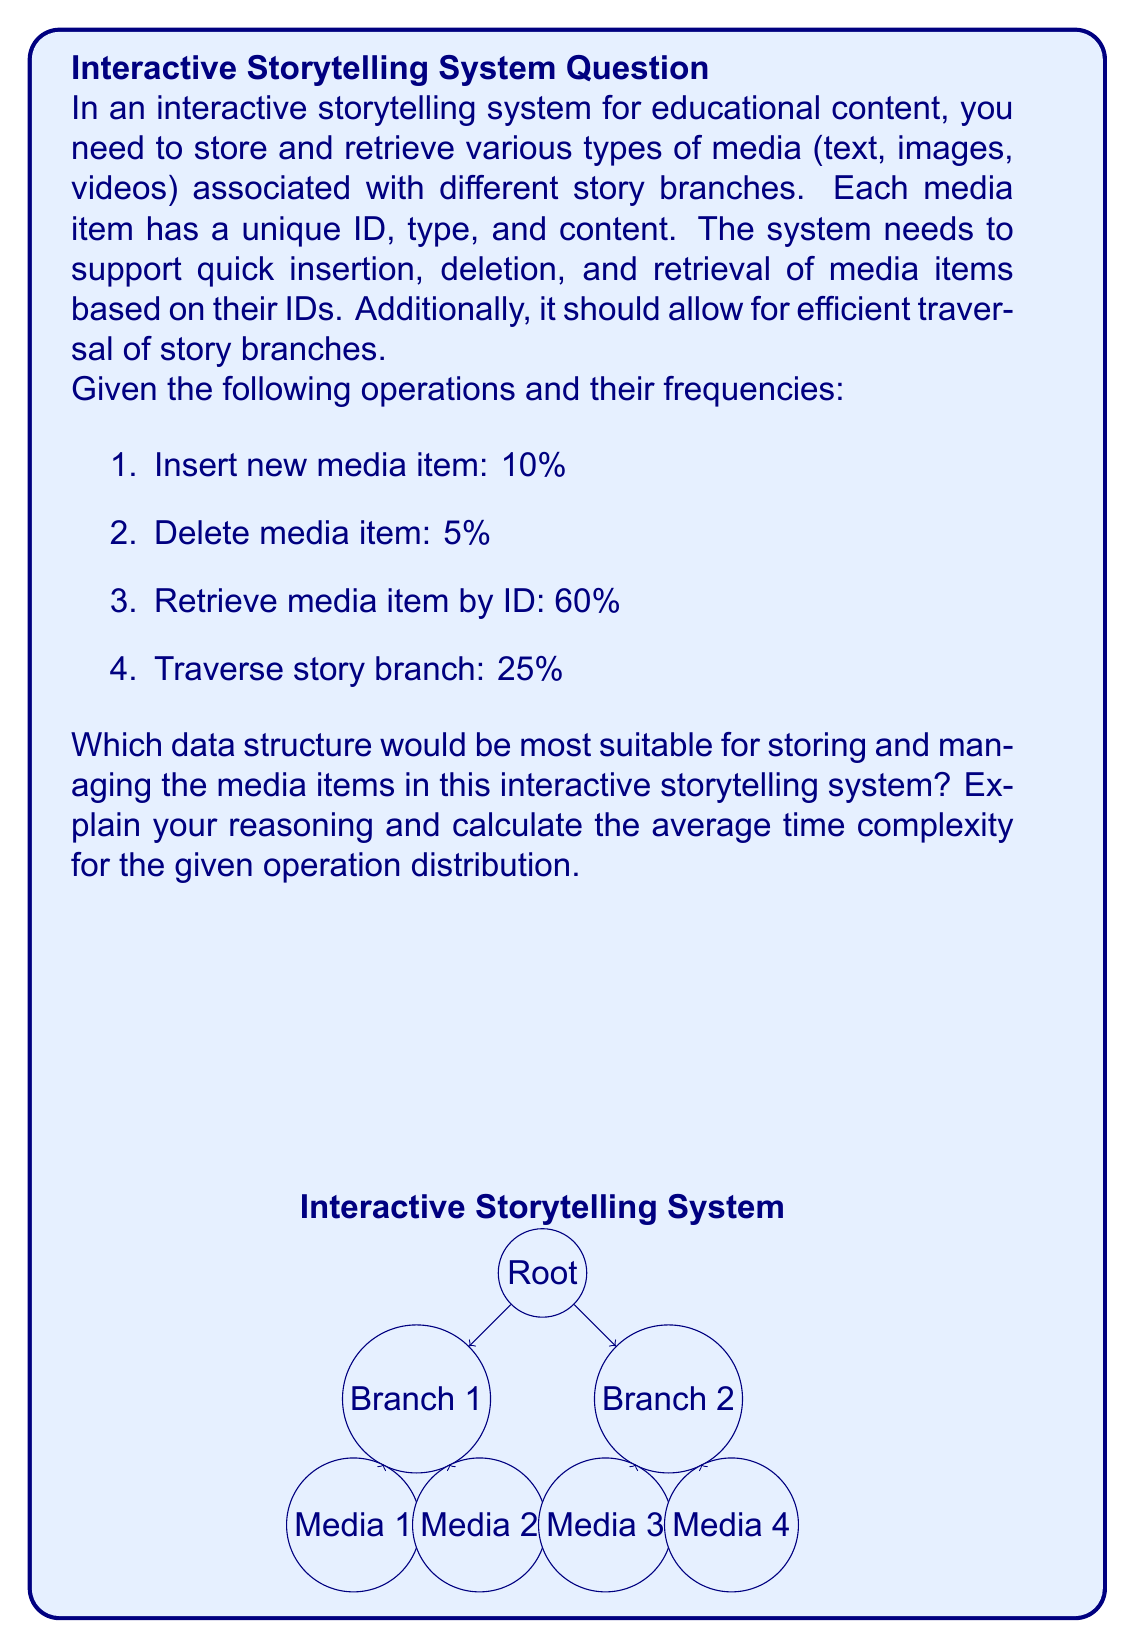Can you solve this math problem? To determine the optimal data structure, we need to consider the requirements and operation frequencies:

1. Quick insertion and deletion: This suggests a dynamic data structure.
2. Efficient retrieval by ID: This indicates the need for a key-value pair structure.
3. Traversal of story branches: This implies a hierarchical or linked structure.

Given these requirements, a combination of data structures would be optimal:

1. Hash Table for media items: This allows for O(1) average-case insertion, deletion, and retrieval by ID.
2. Tree structure for story branches: This enables efficient traversal of the narrative.

Let's analyze the time complexities for each operation:

1. Insert new media item (Hash Table): O(1) average case
2. Delete media item (Hash Table): O(1) average case
3. Retrieve media item by ID (Hash Table): O(1) average case
4. Traverse story branch (Tree): O(n), where n is the number of nodes in the branch

Now, let's calculate the average time complexity based on the given operation frequencies:

$$\begin{align*}
\text{Average Time Complexity} &= 0.10 \cdot O(1) + 0.05 \cdot O(1) + 0.60 \cdot O(1) + 0.25 \cdot O(n) \\
&= 0.75 \cdot O(1) + 0.25 \cdot O(n) \\
&= O(1) + O(n)/4
\end{align*}$$

This results in an average time complexity of O(n/4), which simplifies to O(n).

The combination of a Hash Table for media items and a Tree structure for story branches provides an efficient solution for the interactive storytelling system. It balances quick access to individual media items with the ability to traverse the narrative structure, making it suitable for educational applications in virtual reality environments.
Answer: Hash Table for media items + Tree structure for story branches; Average time complexity: O(n) 